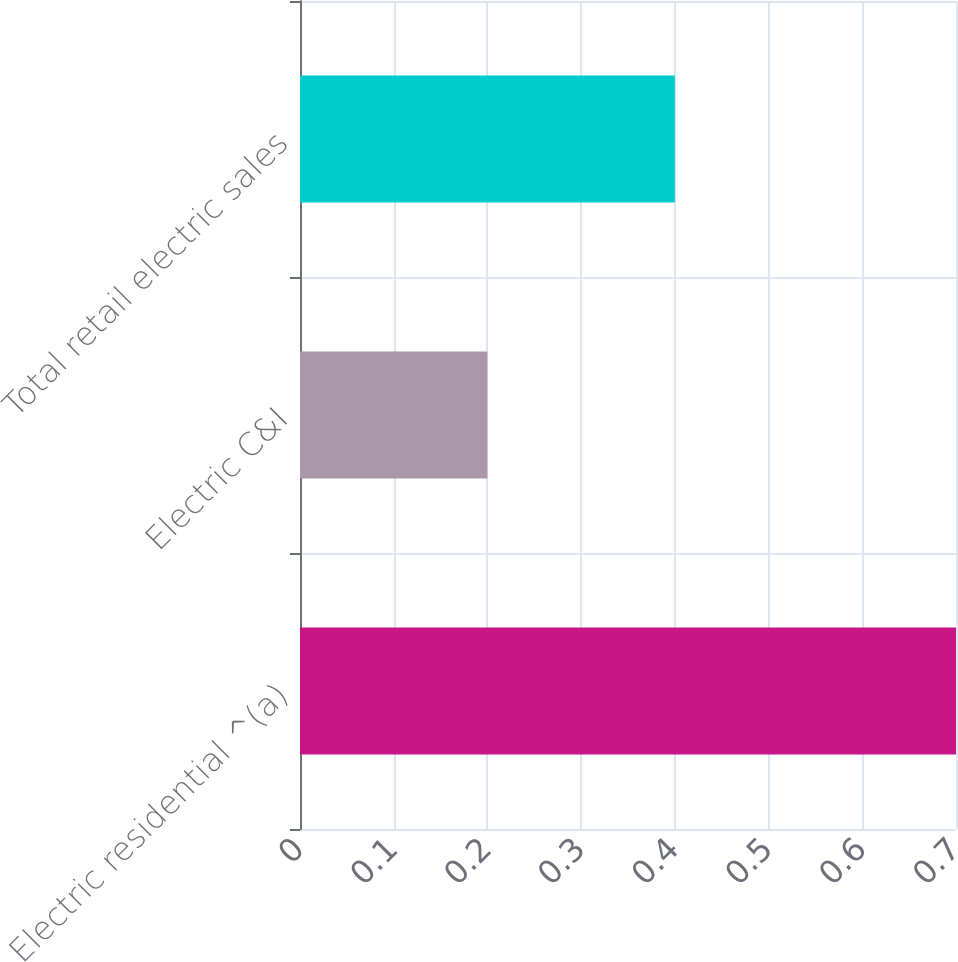<chart> <loc_0><loc_0><loc_500><loc_500><bar_chart><fcel>Electric residential ^(a)<fcel>Electric C&I<fcel>Total retail electric sales<nl><fcel>0.7<fcel>0.2<fcel>0.4<nl></chart> 